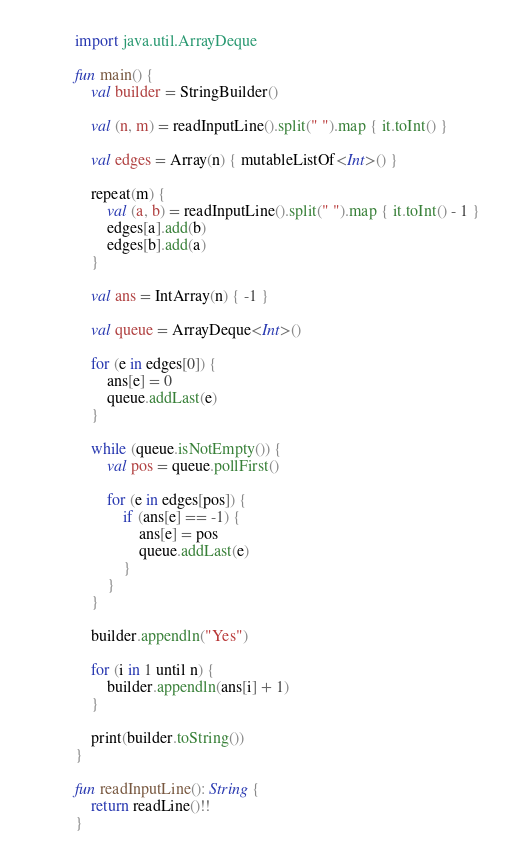Convert code to text. <code><loc_0><loc_0><loc_500><loc_500><_Kotlin_>import java.util.ArrayDeque

fun main() {
    val builder = StringBuilder()

    val (n, m) = readInputLine().split(" ").map { it.toInt() }

    val edges = Array(n) { mutableListOf<Int>() }

    repeat(m) {
        val (a, b) = readInputLine().split(" ").map { it.toInt() - 1 }
        edges[a].add(b)
        edges[b].add(a)
    }

    val ans = IntArray(n) { -1 }

    val queue = ArrayDeque<Int>()

    for (e in edges[0]) {
        ans[e] = 0
        queue.addLast(e)
    }

    while (queue.isNotEmpty()) {
        val pos = queue.pollFirst()

        for (e in edges[pos]) {
            if (ans[e] == -1) {
                ans[e] = pos
                queue.addLast(e)
            }
        }
    }

    builder.appendln("Yes")

    for (i in 1 until n) {
        builder.appendln(ans[i] + 1)
    }

    print(builder.toString())
}

fun readInputLine(): String {
    return readLine()!!
}
</code> 